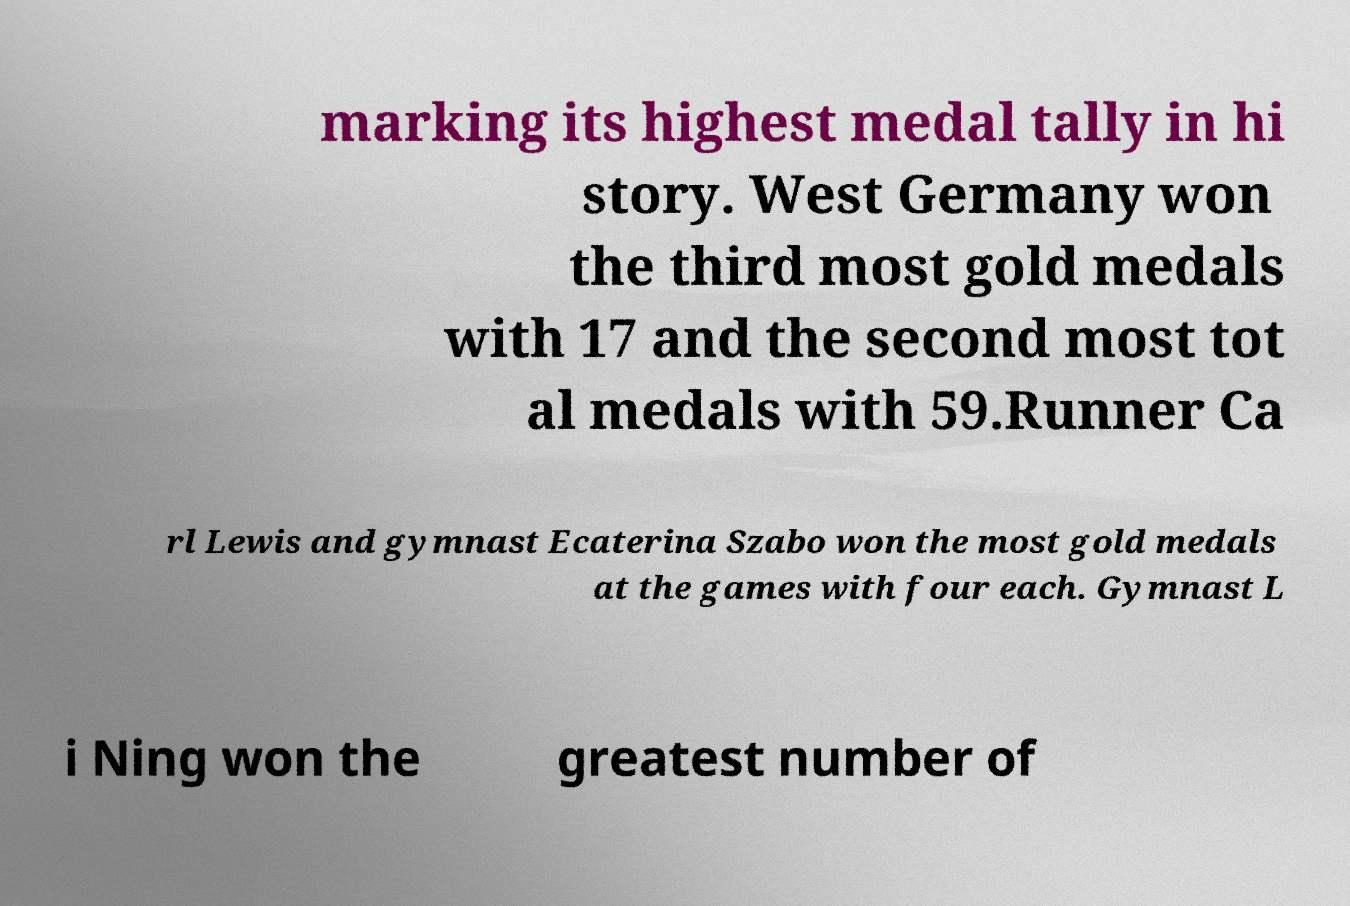Could you extract and type out the text from this image? marking its highest medal tally in hi story. West Germany won the third most gold medals with 17 and the second most tot al medals with 59.Runner Ca rl Lewis and gymnast Ecaterina Szabo won the most gold medals at the games with four each. Gymnast L i Ning won the greatest number of 